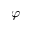Convert formula to latex. <formula><loc_0><loc_0><loc_500><loc_500>\varphi</formula> 